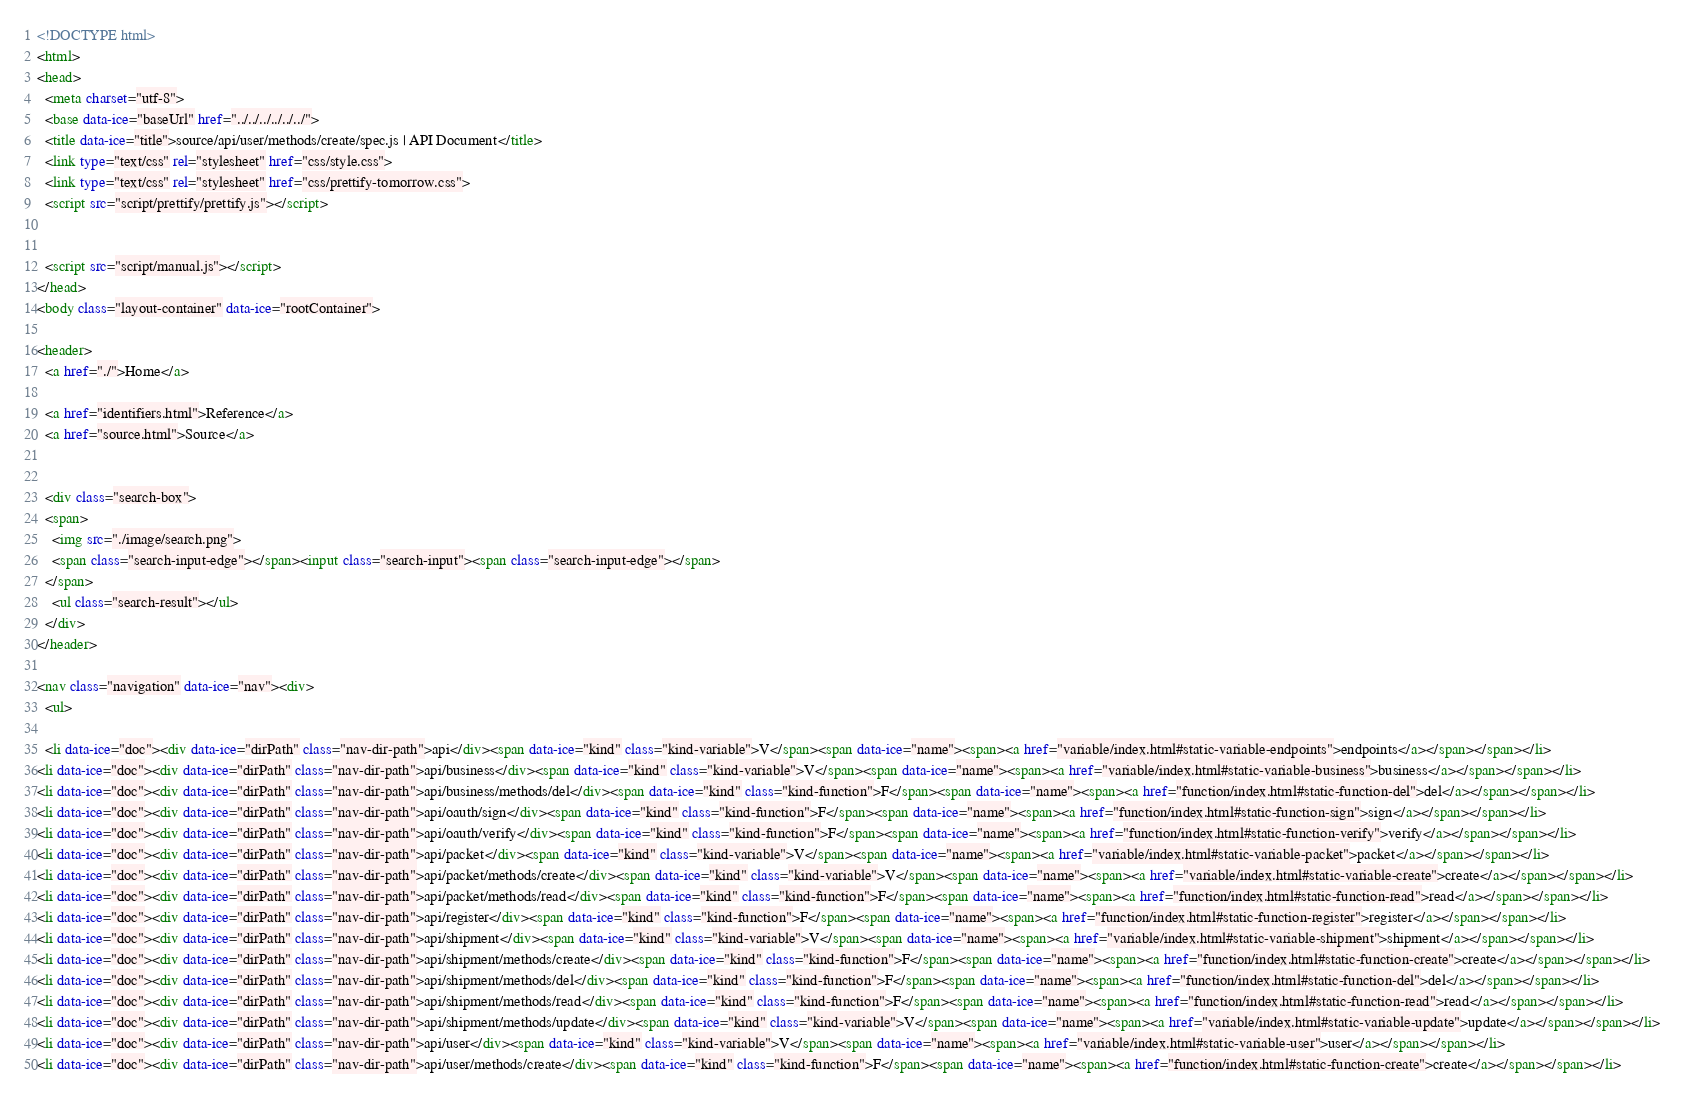Convert code to text. <code><loc_0><loc_0><loc_500><loc_500><_HTML_><!DOCTYPE html>
<html>
<head>
  <meta charset="utf-8">
  <base data-ice="baseUrl" href="../../../../../../">
  <title data-ice="title">source/api/user/methods/create/spec.js | API Document</title>
  <link type="text/css" rel="stylesheet" href="css/style.css">
  <link type="text/css" rel="stylesheet" href="css/prettify-tomorrow.css">
  <script src="script/prettify/prettify.js"></script>
  
  
  <script src="script/manual.js"></script>
</head>
<body class="layout-container" data-ice="rootContainer">

<header>
  <a href="./">Home</a>
  
  <a href="identifiers.html">Reference</a>
  <a href="source.html">Source</a>
  
  
  <div class="search-box">
  <span>
    <img src="./image/search.png">
    <span class="search-input-edge"></span><input class="search-input"><span class="search-input-edge"></span>
  </span>
    <ul class="search-result"></ul>
  </div>
</header>

<nav class="navigation" data-ice="nav"><div>
  <ul>
    
  <li data-ice="doc"><div data-ice="dirPath" class="nav-dir-path">api</div><span data-ice="kind" class="kind-variable">V</span><span data-ice="name"><span><a href="variable/index.html#static-variable-endpoints">endpoints</a></span></span></li>
<li data-ice="doc"><div data-ice="dirPath" class="nav-dir-path">api/business</div><span data-ice="kind" class="kind-variable">V</span><span data-ice="name"><span><a href="variable/index.html#static-variable-business">business</a></span></span></li>
<li data-ice="doc"><div data-ice="dirPath" class="nav-dir-path">api/business/methods/del</div><span data-ice="kind" class="kind-function">F</span><span data-ice="name"><span><a href="function/index.html#static-function-del">del</a></span></span></li>
<li data-ice="doc"><div data-ice="dirPath" class="nav-dir-path">api/oauth/sign</div><span data-ice="kind" class="kind-function">F</span><span data-ice="name"><span><a href="function/index.html#static-function-sign">sign</a></span></span></li>
<li data-ice="doc"><div data-ice="dirPath" class="nav-dir-path">api/oauth/verify</div><span data-ice="kind" class="kind-function">F</span><span data-ice="name"><span><a href="function/index.html#static-function-verify">verify</a></span></span></li>
<li data-ice="doc"><div data-ice="dirPath" class="nav-dir-path">api/packet</div><span data-ice="kind" class="kind-variable">V</span><span data-ice="name"><span><a href="variable/index.html#static-variable-packet">packet</a></span></span></li>
<li data-ice="doc"><div data-ice="dirPath" class="nav-dir-path">api/packet/methods/create</div><span data-ice="kind" class="kind-variable">V</span><span data-ice="name"><span><a href="variable/index.html#static-variable-create">create</a></span></span></li>
<li data-ice="doc"><div data-ice="dirPath" class="nav-dir-path">api/packet/methods/read</div><span data-ice="kind" class="kind-function">F</span><span data-ice="name"><span><a href="function/index.html#static-function-read">read</a></span></span></li>
<li data-ice="doc"><div data-ice="dirPath" class="nav-dir-path">api/register</div><span data-ice="kind" class="kind-function">F</span><span data-ice="name"><span><a href="function/index.html#static-function-register">register</a></span></span></li>
<li data-ice="doc"><div data-ice="dirPath" class="nav-dir-path">api/shipment</div><span data-ice="kind" class="kind-variable">V</span><span data-ice="name"><span><a href="variable/index.html#static-variable-shipment">shipment</a></span></span></li>
<li data-ice="doc"><div data-ice="dirPath" class="nav-dir-path">api/shipment/methods/create</div><span data-ice="kind" class="kind-function">F</span><span data-ice="name"><span><a href="function/index.html#static-function-create">create</a></span></span></li>
<li data-ice="doc"><div data-ice="dirPath" class="nav-dir-path">api/shipment/methods/del</div><span data-ice="kind" class="kind-function">F</span><span data-ice="name"><span><a href="function/index.html#static-function-del">del</a></span></span></li>
<li data-ice="doc"><div data-ice="dirPath" class="nav-dir-path">api/shipment/methods/read</div><span data-ice="kind" class="kind-function">F</span><span data-ice="name"><span><a href="function/index.html#static-function-read">read</a></span></span></li>
<li data-ice="doc"><div data-ice="dirPath" class="nav-dir-path">api/shipment/methods/update</div><span data-ice="kind" class="kind-variable">V</span><span data-ice="name"><span><a href="variable/index.html#static-variable-update">update</a></span></span></li>
<li data-ice="doc"><div data-ice="dirPath" class="nav-dir-path">api/user</div><span data-ice="kind" class="kind-variable">V</span><span data-ice="name"><span><a href="variable/index.html#static-variable-user">user</a></span></span></li>
<li data-ice="doc"><div data-ice="dirPath" class="nav-dir-path">api/user/methods/create</div><span data-ice="kind" class="kind-function">F</span><span data-ice="name"><span><a href="function/index.html#static-function-create">create</a></span></span></li></code> 